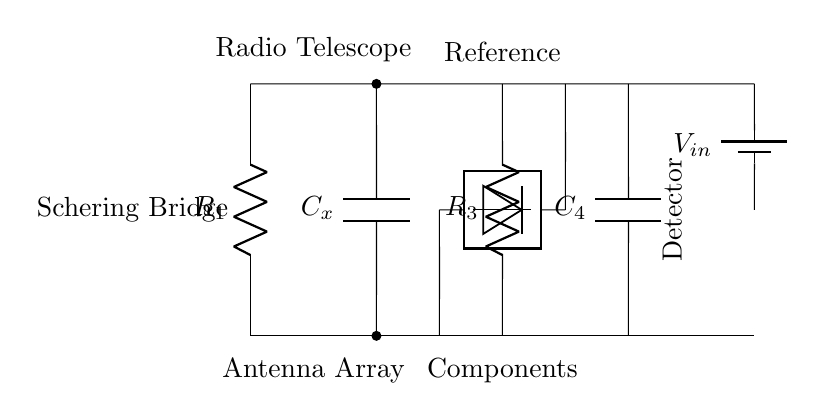What type of bridge is used in this circuit? The circuit shown is a Schering bridge, which is specifically used for measuring capacitance. The presence of capacitor components in the layout distinguishes it as a Schering bridge compared to other types of bridges.
Answer: Schering bridge What components are present in the circuit? The circuit consists of two resistors (R1, R3), two capacitors (Cx, C4), a voltage source (Vin), and a detector. Each component is labeled in the diagram, allowing for easy identification.
Answer: R1, R3, Cx, C4, Vin, detector Where is the detector positioned in the circuit? The detector is located between two nodes of the bridge, specifically between the connections from the resistors and capacitors. Its position is crucial for measuring the potential difference that indicates balance in the bridge.
Answer: Between the nodes of R3 and C4 What is the function of the capacitors in the circuit? The capacitors (Cx and C4) are used to measure the unknown capacitance (Cx) through comparison with the known capacitance (C4). Their arrangement in the bridge allows for balancing the circuit, leading to the measurement of the unknown component.
Answer: Measure unknown capacitance How does the voltage source affect the detector reading? The voltage source (Vin) provides the necessary potential difference across the circuit. When the bridge is balanced, the voltage across the detector becomes zero, indicating that the capacitance values are equal. This is fundamental for the function of a Schering bridge, as it directly influences the detector's readings.
Answer: It provides the potential difference What happens to the readings of the detector when the bridge is unbalanced? When the bridge is unbalanced, the detector will read a non-zero voltage, reflecting the difference in capacitance or resistance in the circuit. This condition implies that the capacitors or resistors need adjustment to achieve a balanced state and accurate measurement.
Answer: Non-zero voltage What is the role of the reference components in this bridge? The reference components (typically the known capacitor and resistor) serve as a standard against which the unknown components are measured. In the case of a Schering bridge, one capacitor is adjusted until the detector indicates that there is no voltage, signifying a balanced condition.
Answer: Serve as standards 